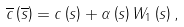<formula> <loc_0><loc_0><loc_500><loc_500>\overline { c } \left ( \overline { s } \right ) = c \left ( s \right ) + \alpha \left ( s \right ) W _ { 1 } \left ( s \right ) ,</formula> 